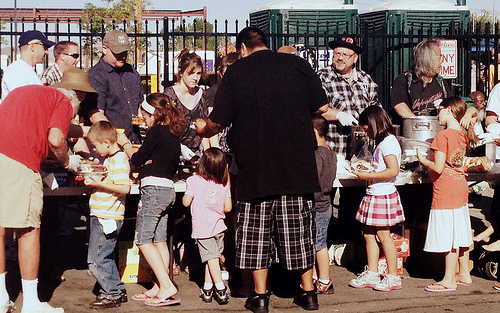<image>
Can you confirm if the hat is on the woman? Yes. Looking at the image, I can see the hat is positioned on top of the woman, with the woman providing support. Is there a girl to the left of the plate? No. The girl is not to the left of the plate. From this viewpoint, they have a different horizontal relationship. Where is the man in relation to the fence? Is it behind the fence? No. The man is not behind the fence. From this viewpoint, the man appears to be positioned elsewhere in the scene. 